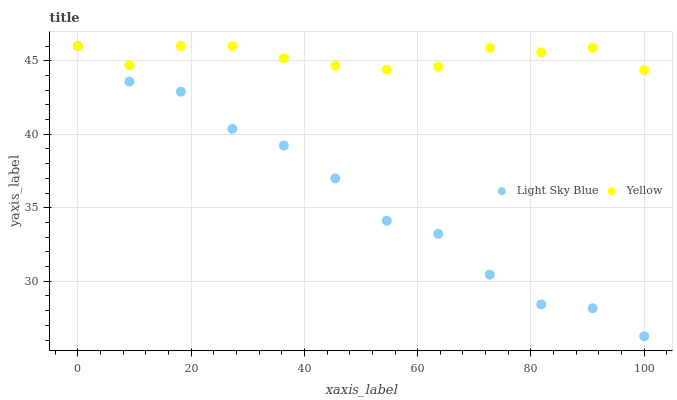Does Light Sky Blue have the minimum area under the curve?
Answer yes or no. Yes. Does Yellow have the maximum area under the curve?
Answer yes or no. Yes. Does Yellow have the minimum area under the curve?
Answer yes or no. No. Is Yellow the smoothest?
Answer yes or no. Yes. Is Light Sky Blue the roughest?
Answer yes or no. Yes. Is Yellow the roughest?
Answer yes or no. No. Does Light Sky Blue have the lowest value?
Answer yes or no. Yes. Does Yellow have the lowest value?
Answer yes or no. No. Does Yellow have the highest value?
Answer yes or no. Yes. Does Yellow intersect Light Sky Blue?
Answer yes or no. Yes. Is Yellow less than Light Sky Blue?
Answer yes or no. No. Is Yellow greater than Light Sky Blue?
Answer yes or no. No. 